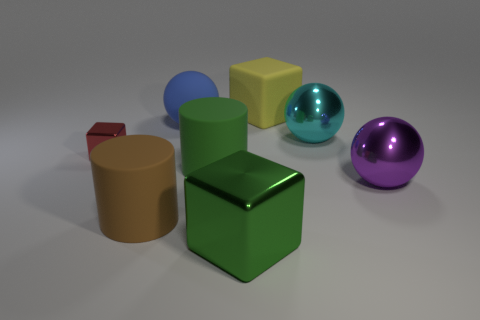Subtract all big cyan metal balls. How many balls are left? 2 Subtract all yellow cubes. How many cubes are left? 2 Subtract all blocks. How many objects are left? 5 Subtract 2 cubes. How many cubes are left? 1 Add 1 large matte things. How many objects exist? 9 Subtract all cyan cylinders. How many blue spheres are left? 1 Add 6 green matte cylinders. How many green matte cylinders exist? 7 Subtract 0 red cylinders. How many objects are left? 8 Subtract all gray spheres. Subtract all cyan cubes. How many spheres are left? 3 Subtract all gray matte things. Subtract all cyan spheres. How many objects are left? 7 